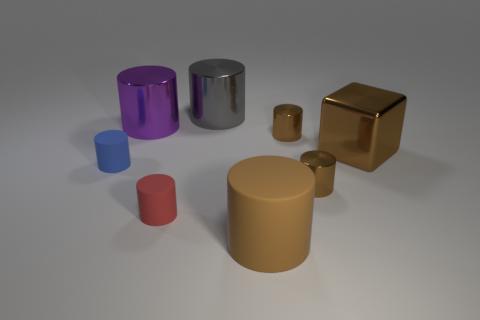Subtract all big gray metallic cylinders. How many cylinders are left? 6 Subtract all gray blocks. How many brown cylinders are left? 3 Subtract all purple cylinders. How many cylinders are left? 6 Add 2 small brown rubber things. How many objects exist? 10 Add 8 tiny brown shiny objects. How many tiny brown shiny objects are left? 10 Add 5 gray shiny cylinders. How many gray shiny cylinders exist? 6 Subtract 0 red balls. How many objects are left? 8 Subtract all cylinders. How many objects are left? 1 Subtract all cyan cylinders. Subtract all cyan balls. How many cylinders are left? 7 Subtract all big purple rubber blocks. Subtract all big cylinders. How many objects are left? 5 